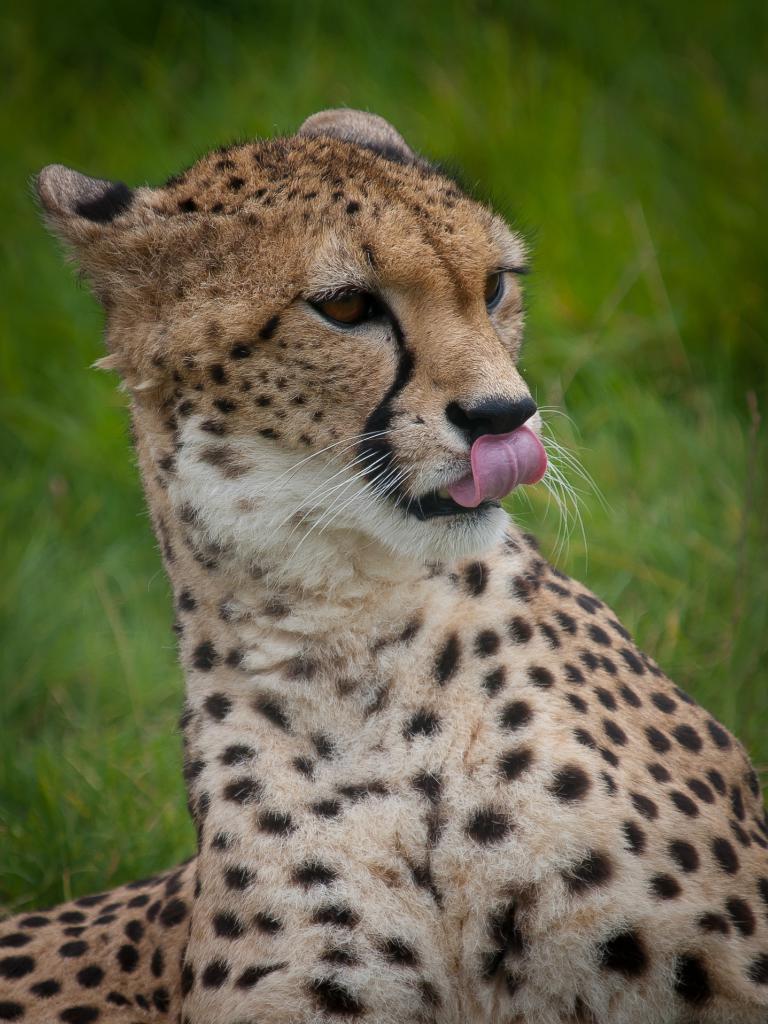Describe this image in one or two sentences. In this image I can see an animal which is in brown and black. Background I can see grass in green color. 